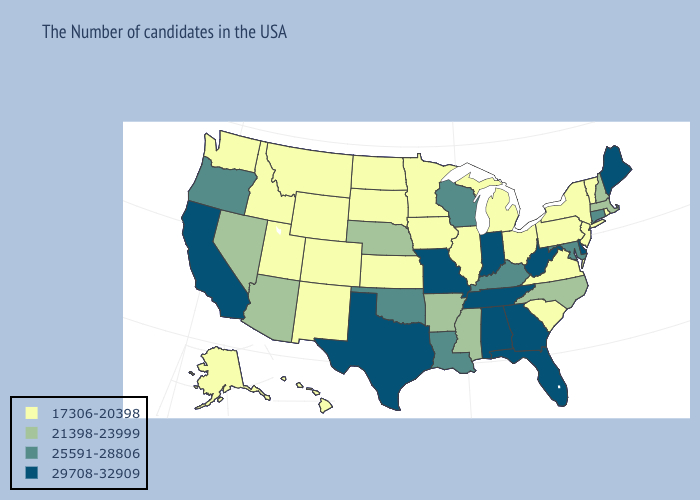What is the value of Utah?
Give a very brief answer. 17306-20398. Does Wyoming have the same value as Idaho?
Give a very brief answer. Yes. Name the states that have a value in the range 29708-32909?
Be succinct. Maine, Delaware, West Virginia, Florida, Georgia, Indiana, Alabama, Tennessee, Missouri, Texas, California. Does Arizona have the lowest value in the West?
Short answer required. No. Name the states that have a value in the range 29708-32909?
Write a very short answer. Maine, Delaware, West Virginia, Florida, Georgia, Indiana, Alabama, Tennessee, Missouri, Texas, California. Name the states that have a value in the range 17306-20398?
Keep it brief. Rhode Island, Vermont, New York, New Jersey, Pennsylvania, Virginia, South Carolina, Ohio, Michigan, Illinois, Minnesota, Iowa, Kansas, South Dakota, North Dakota, Wyoming, Colorado, New Mexico, Utah, Montana, Idaho, Washington, Alaska, Hawaii. What is the value of Georgia?
Short answer required. 29708-32909. Name the states that have a value in the range 21398-23999?
Concise answer only. Massachusetts, New Hampshire, North Carolina, Mississippi, Arkansas, Nebraska, Arizona, Nevada. What is the value of Colorado?
Answer briefly. 17306-20398. Name the states that have a value in the range 17306-20398?
Answer briefly. Rhode Island, Vermont, New York, New Jersey, Pennsylvania, Virginia, South Carolina, Ohio, Michigan, Illinois, Minnesota, Iowa, Kansas, South Dakota, North Dakota, Wyoming, Colorado, New Mexico, Utah, Montana, Idaho, Washington, Alaska, Hawaii. Which states have the lowest value in the USA?
Quick response, please. Rhode Island, Vermont, New York, New Jersey, Pennsylvania, Virginia, South Carolina, Ohio, Michigan, Illinois, Minnesota, Iowa, Kansas, South Dakota, North Dakota, Wyoming, Colorado, New Mexico, Utah, Montana, Idaho, Washington, Alaska, Hawaii. What is the value of Mississippi?
Concise answer only. 21398-23999. Among the states that border Nebraska , which have the lowest value?
Give a very brief answer. Iowa, Kansas, South Dakota, Wyoming, Colorado. Name the states that have a value in the range 17306-20398?
Keep it brief. Rhode Island, Vermont, New York, New Jersey, Pennsylvania, Virginia, South Carolina, Ohio, Michigan, Illinois, Minnesota, Iowa, Kansas, South Dakota, North Dakota, Wyoming, Colorado, New Mexico, Utah, Montana, Idaho, Washington, Alaska, Hawaii. What is the value of Virginia?
Be succinct. 17306-20398. 